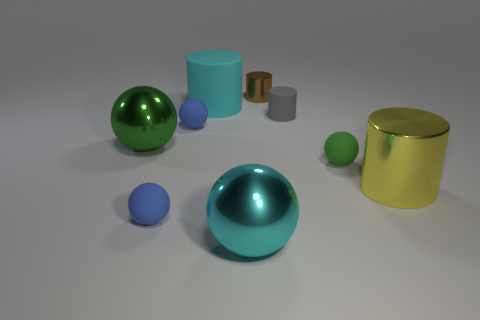What are the colors of the objects positioned closest to the cyan sphere? The objects closest to the cyan sphere are colored yellow and green. Specifically, the yellow is a metal cylinder, and the green is another sphere.  Are there any objects that seem to have a reflective surface? Yes, several objects in the image have reflective surfaces. Most notably, the cyan and green spheres, and the metal cylinders, highlight reflective properties that make them stand out. 